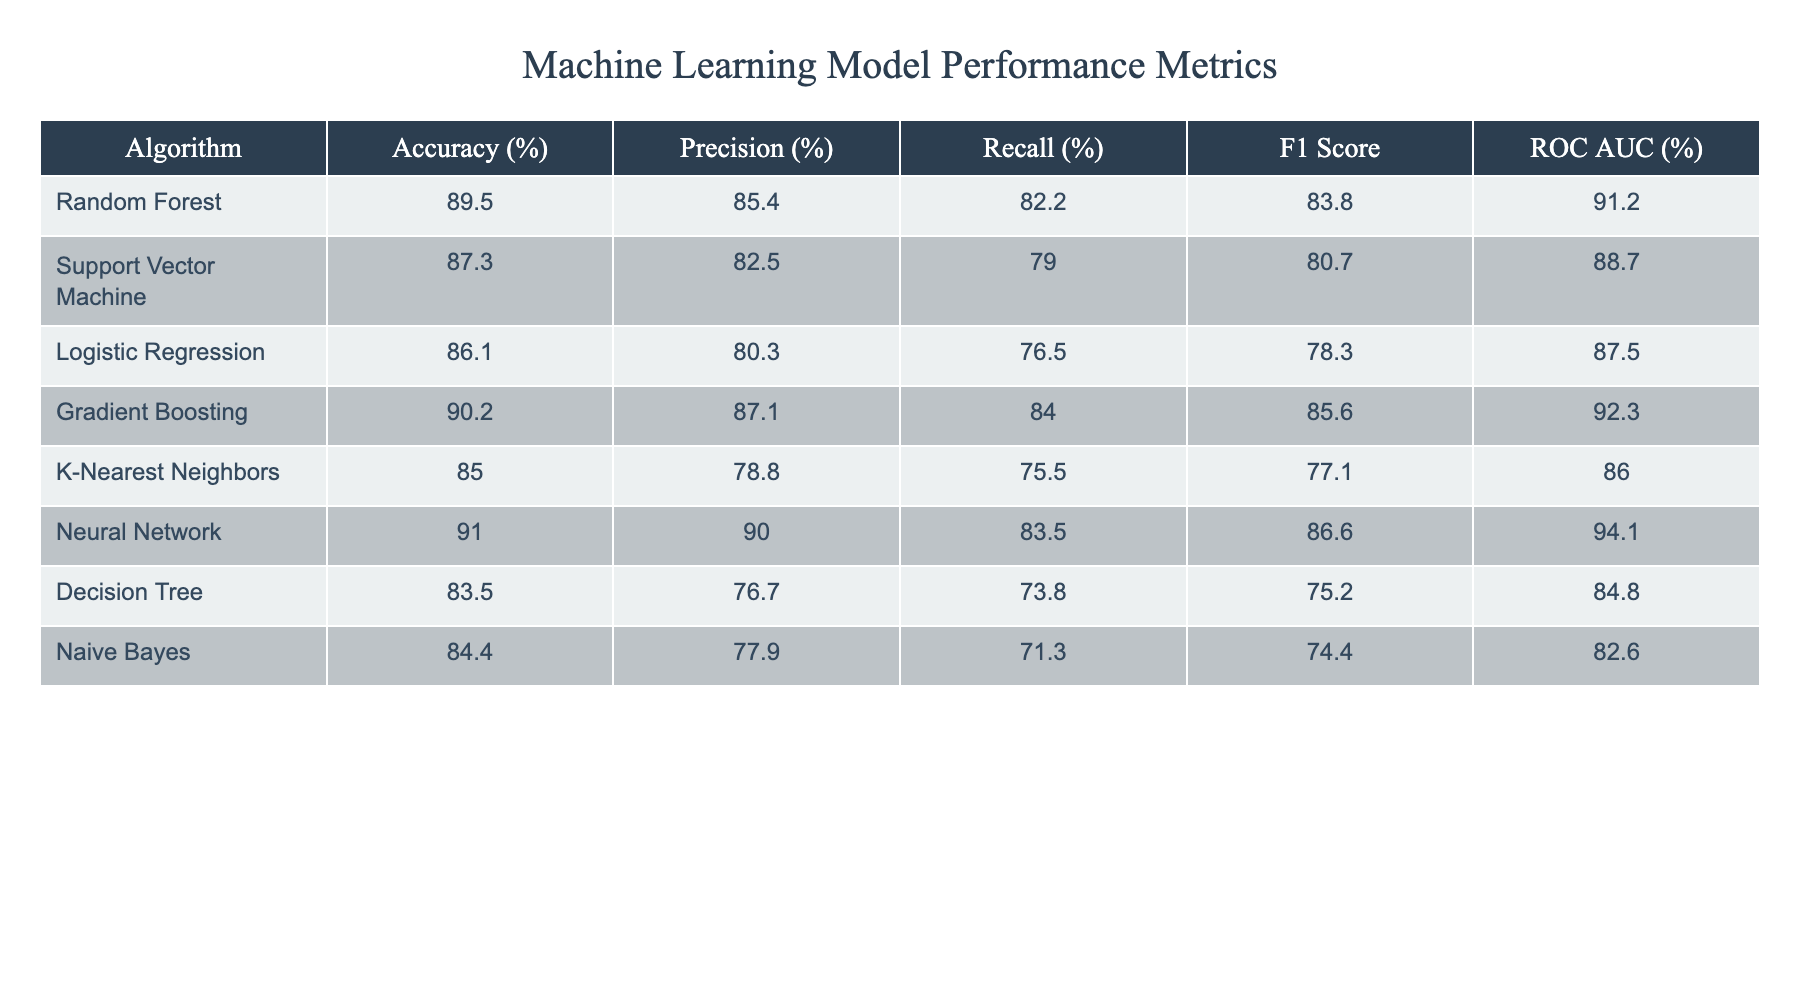What is the accuracy of the Neural Network algorithm? The accuracy of the Neural Network algorithm is explicitly stated in the table as 91.0%.
Answer: 91.0% Which algorithm has the highest F1 Score? I can look at the F1 Score column in the table. The F1 Score for the Neural Network is 86.6, which is higher than all other algorithms listed.
Answer: Neural Network Is the Precision of the Support Vector Machine algorithm greater than 80%? The Precision for the Support Vector Machine is 82.5%, which is indeed greater than 80%.
Answer: Yes What is the average Recall across all algorithms? To find the average Recall, sum all Recall values: (82.2 + 79.0 + 76.5 + 84.0 + 75.5 + 83.5 + 73.8 + 71.3) = 605.8. There are 8 algorithms, so the average Recall is 605.8 / 8 = 75.725, which rounds to 75.7%.
Answer: 75.7% Which algorithm has the lowest ROC AUC? By examining the ROC AUC column, I see that the Naive Bayes algorithm has the lowest value at 82.6%.
Answer: Naive Bayes Is it true that the Random Forest algorithm outperforms the Logistic Regression in both Accuracy and F1 Score? The Random Forest has an Accuracy of 89.5% and F1 Score of 83.8, while Logistic Regression has an Accuracy of 86.1% and an F1 Score of 78.3. Both metrics for Random Forest are higher than those for Logistic Regression.
Answer: Yes What is the difference in Accuracy between the Gradient Boosting and K-Nearest Neighbors algorithms? The Accuracy of Gradient Boosting is 90.2% and that of K-Nearest Neighbors is 85.0%. The difference is 90.2 - 85.0 = 5.2%.
Answer: 5.2% What percentage of algorithms have an ROC AUC above 90%? The algorithms with ROC AUC above 90% are Neural Network (94.1%) and Gradient Boosting (92.3%), making a total of 2 out of 8 algorithms, which is (2/8) * 100 = 25%.
Answer: 25% 